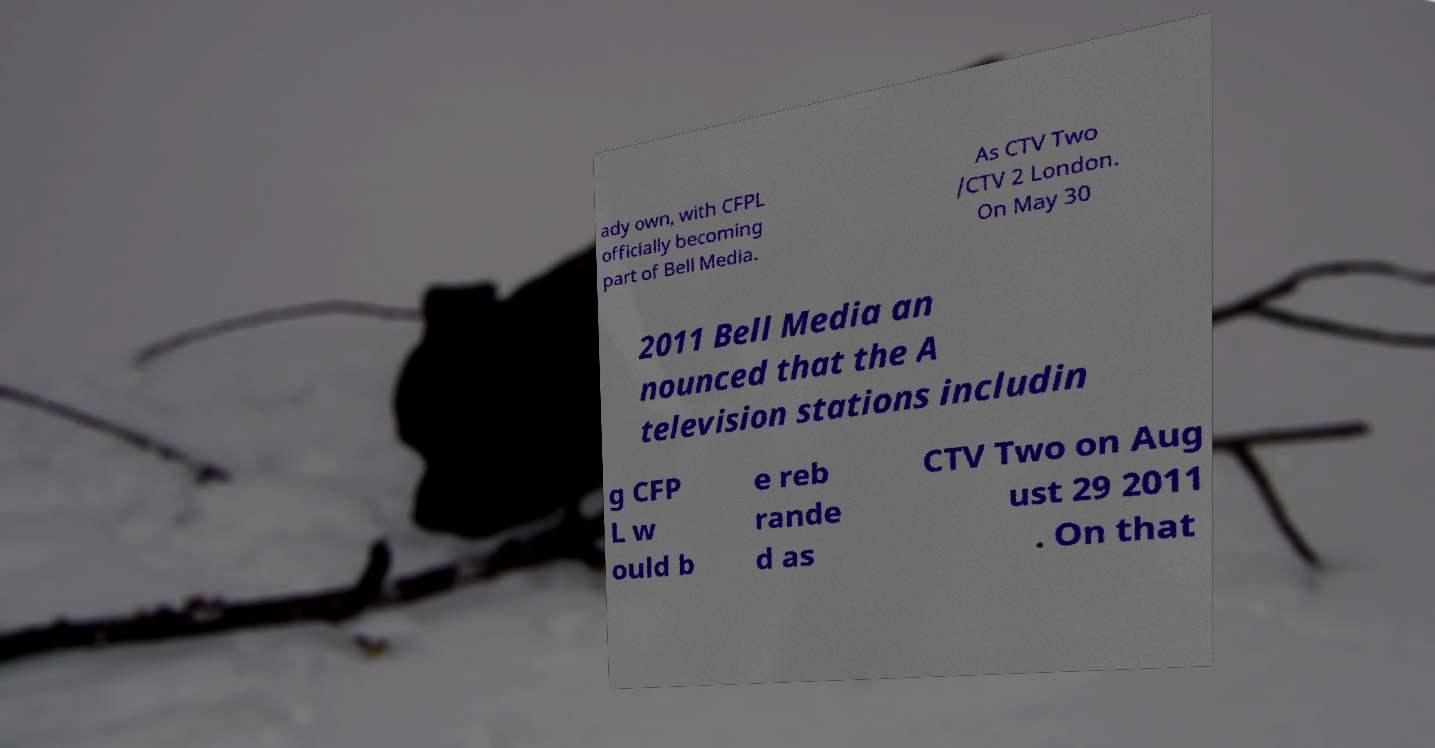Could you extract and type out the text from this image? ady own, with CFPL officially becoming part of Bell Media. As CTV Two /CTV 2 London. On May 30 2011 Bell Media an nounced that the A television stations includin g CFP L w ould b e reb rande d as CTV Two on Aug ust 29 2011 . On that 